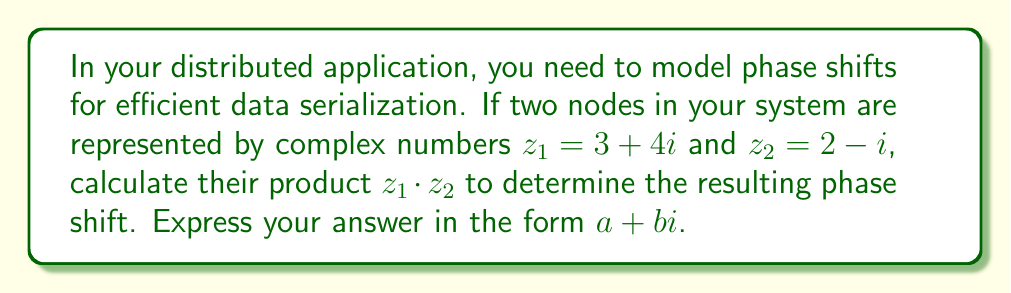Can you answer this question? To multiply two complex numbers, we use the distributive property and the fact that $i^2 = -1$. Let's break it down step-by-step:

1) We have $z_1 = 3 + 4i$ and $z_2 = 2 - i$

2) Multiply these numbers:
   $z_1 \cdot z_2 = (3 + 4i)(2 - i)$

3) Use the FOIL method to multiply:
   $(3 \cdot 2) + (3 \cdot (-i)) + (4i \cdot 2) + (4i \cdot (-i))$

4) Simplify:
   $6 - 3i + 8i - 4i^2$

5) Combine like terms and remember that $i^2 = -1$:
   $6 + 5i - 4(-1)$

6) Simplify further:
   $6 + 5i + 4 = 10 + 5i$

The resulting complex number $10 + 5i$ represents the phase shift in your distributed system after the multiplication operation.
Answer: $10 + 5i$ 